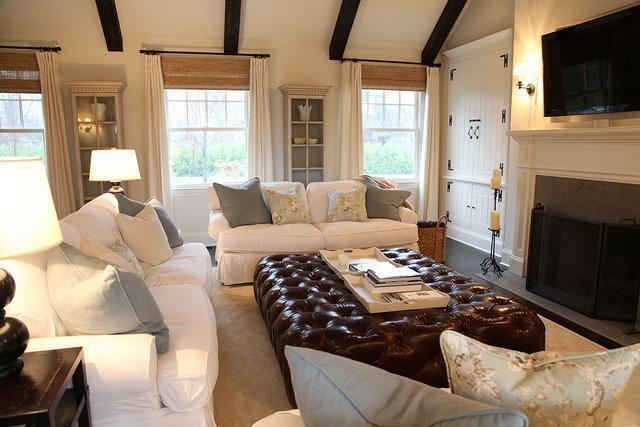How many couches are in the photo?
Give a very brief answer. 2. 